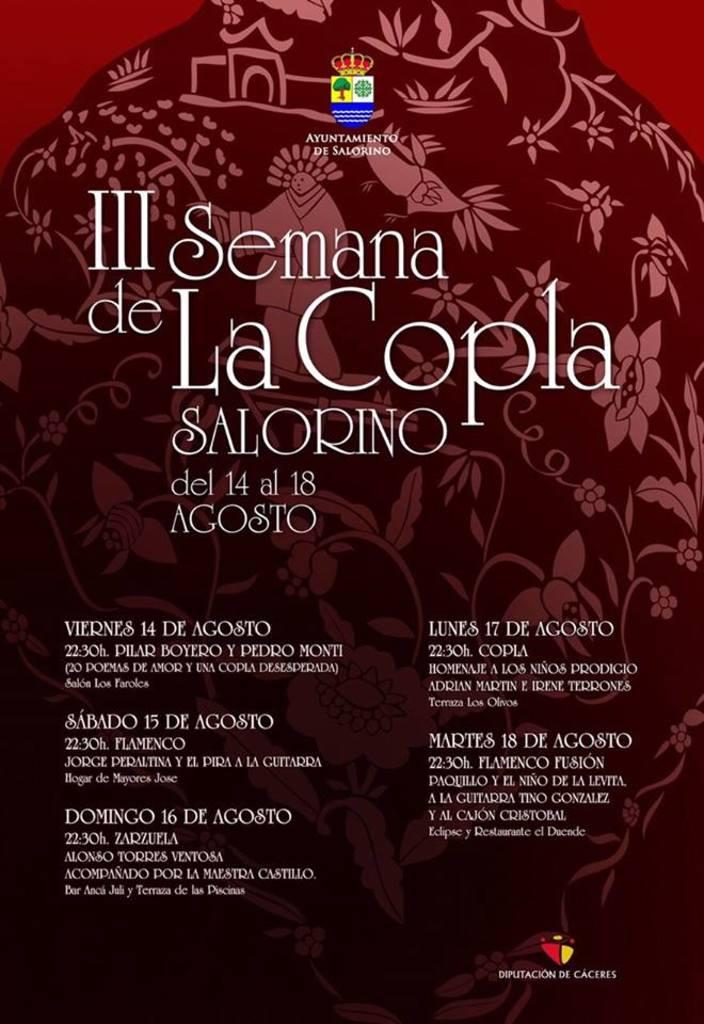<image>
Write a terse but informative summary of the picture. a poster for semana de La Copla on it 